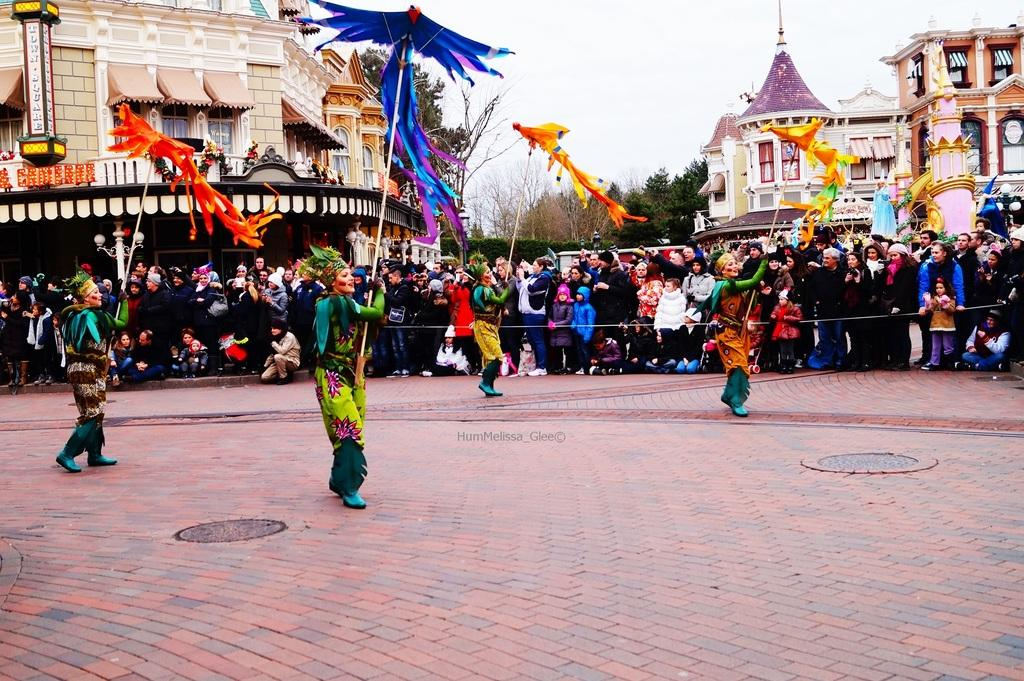What are the persons in the image doing? The persons in the image are performing. Where is the performance taking place? The performance is taking place on the road. What can be seen in the background of the image? There is a crowd, buildings, trees, and the sky visible in the background of the image. What type of nerve can be seen in the image? There is no nerve present in the image; it features a performance taking place on the road. How many sticks are being used by the performers in the image? There is no mention of sticks being used by the performers in the image. 